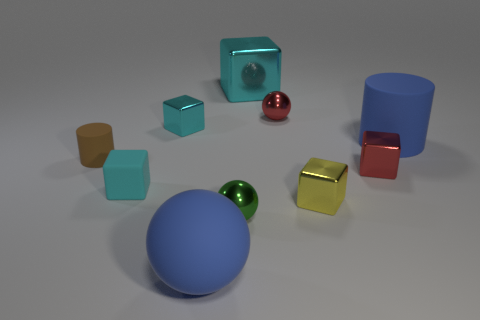Subtract all cyan blocks. How many were subtracted if there are1cyan blocks left? 2 Subtract all small green metal balls. How many balls are left? 2 Subtract all green balls. How many balls are left? 2 Subtract all cylinders. How many objects are left? 8 Subtract 1 cylinders. How many cylinders are left? 1 Subtract all gray spheres. How many red blocks are left? 1 Subtract all red shiny cubes. Subtract all yellow cubes. How many objects are left? 8 Add 9 tiny red blocks. How many tiny red blocks are left? 10 Add 2 green shiny spheres. How many green shiny spheres exist? 3 Subtract 0 cyan cylinders. How many objects are left? 10 